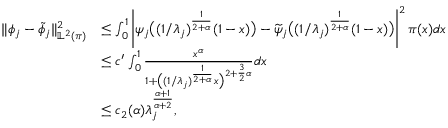<formula> <loc_0><loc_0><loc_500><loc_500>\begin{array} { r l } { \| \phi _ { j } - \widetilde { \phi } _ { j } \| _ { \mathbb { L } ^ { 2 } ( \pi ) } ^ { 2 } } & { \leq \int _ { 0 } ^ { 1 } \left | \psi _ { j } \left ( ( 1 / \lambda _ { j } ) ^ { \frac { 1 } { 2 + \alpha } } ( 1 - x ) \right ) - \widetilde { \psi } _ { j } \left ( ( 1 / \lambda _ { j } ) ^ { \frac { 1 } { 2 + \alpha } } ( 1 - x ) \right ) \right | ^ { 2 } \pi ( x ) d x } \\ & { \leq c ^ { \prime } \int _ { 0 } ^ { 1 } \frac { x ^ { \alpha } } { 1 + \left ( ( 1 / \lambda _ { j } ) ^ { \frac { 1 } { 2 + \alpha } } x \right ) ^ { 2 + \frac { 3 } { 2 } \alpha } } d x } \\ & { \leq c _ { 2 } ( \alpha ) \lambda _ { j } ^ { \frac { \alpha + 1 } { \alpha + 2 } } , } \end{array}</formula> 